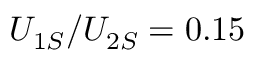<formula> <loc_0><loc_0><loc_500><loc_500>U _ { 1 S } / U _ { 2 S } = 0 . 1 5</formula> 